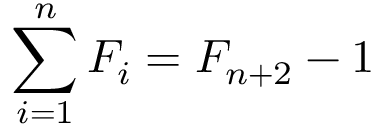Convert formula to latex. <formula><loc_0><loc_0><loc_500><loc_500>\sum _ { i = 1 } ^ { n } F _ { i } = F _ { n + 2 } - 1</formula> 